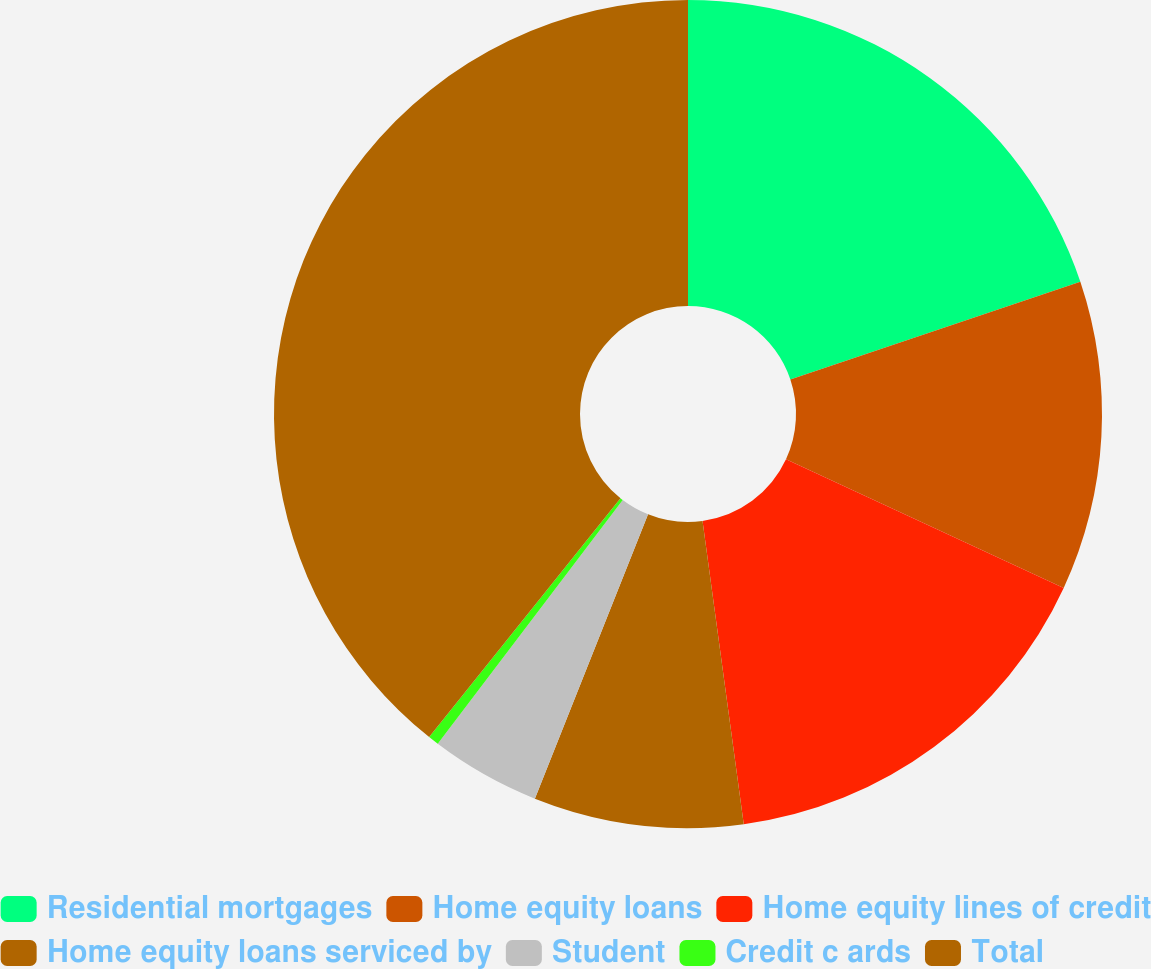<chart> <loc_0><loc_0><loc_500><loc_500><pie_chart><fcel>Residential mortgages<fcel>Home equity loans<fcel>Home equity lines of credit<fcel>Home equity loans serviced by<fcel>Student<fcel>Credit c ards<fcel>Total<nl><fcel>19.83%<fcel>12.07%<fcel>15.95%<fcel>8.18%<fcel>4.3%<fcel>0.42%<fcel>39.25%<nl></chart> 